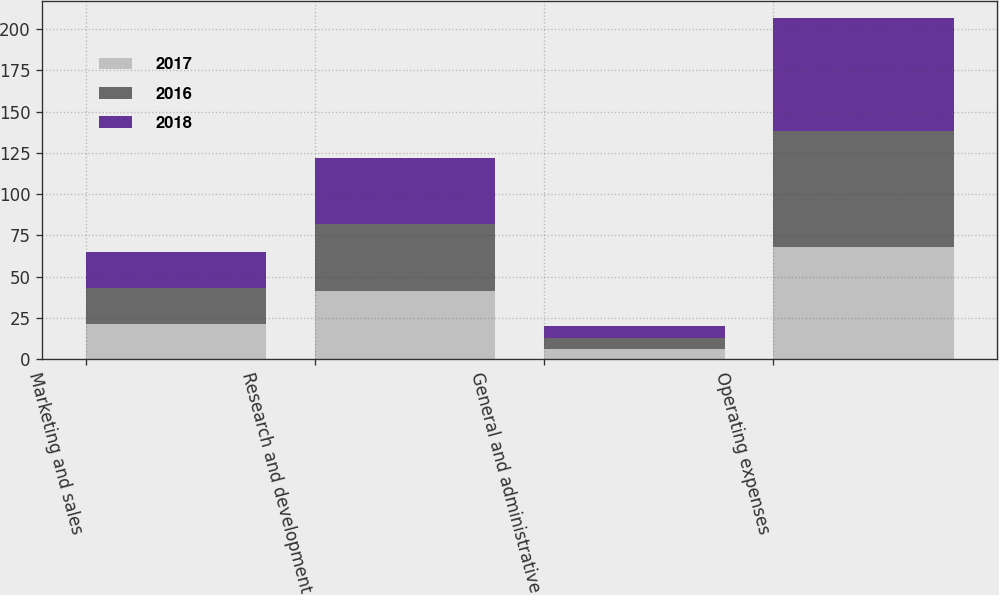Convert chart to OTSL. <chart><loc_0><loc_0><loc_500><loc_500><stacked_bar_chart><ecel><fcel>Marketing and sales<fcel>Research and development<fcel>General and administrative<fcel>Operating expenses<nl><fcel>2017<fcel>21<fcel>41<fcel>6<fcel>68<nl><fcel>2016<fcel>22<fcel>41<fcel>7<fcel>70<nl><fcel>2018<fcel>22<fcel>40<fcel>7<fcel>69<nl></chart> 